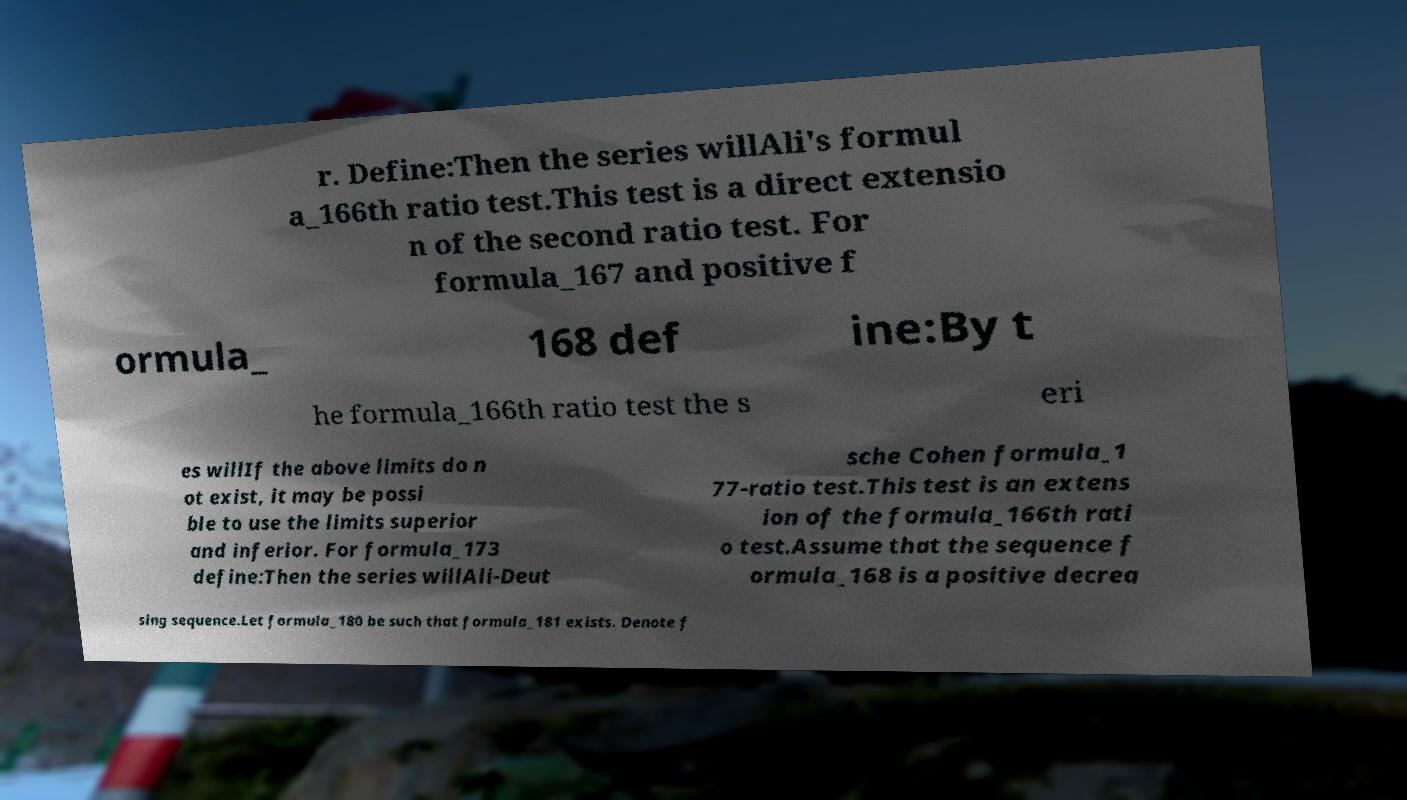Can you read and provide the text displayed in the image?This photo seems to have some interesting text. Can you extract and type it out for me? r. Define:Then the series willAli's formul a_166th ratio test.This test is a direct extensio n of the second ratio test. For formula_167 and positive f ormula_ 168 def ine:By t he formula_166th ratio test the s eri es willIf the above limits do n ot exist, it may be possi ble to use the limits superior and inferior. For formula_173 define:Then the series willAli-Deut sche Cohen formula_1 77-ratio test.This test is an extens ion of the formula_166th rati o test.Assume that the sequence f ormula_168 is a positive decrea sing sequence.Let formula_180 be such that formula_181 exists. Denote f 